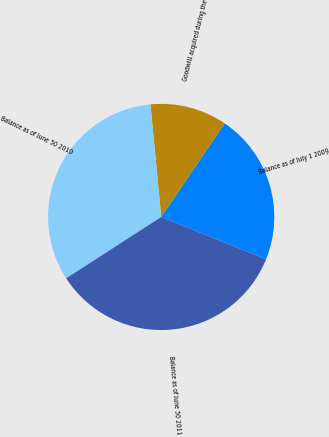Convert chart. <chart><loc_0><loc_0><loc_500><loc_500><pie_chart><fcel>Balance as of July 1 2009<fcel>Goodwill acquired during the<fcel>Balance as of June 30 2010<fcel>Balance as of June 30 2011<nl><fcel>21.61%<fcel>11.01%<fcel>32.61%<fcel>34.77%<nl></chart> 